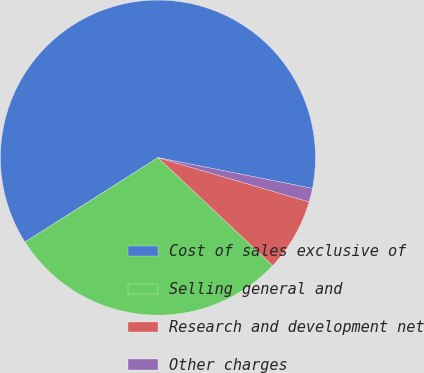Convert chart to OTSL. <chart><loc_0><loc_0><loc_500><loc_500><pie_chart><fcel>Cost of sales exclusive of<fcel>Selling general and<fcel>Research and development net<fcel>Other charges<nl><fcel>62.13%<fcel>28.98%<fcel>7.48%<fcel>1.41%<nl></chart> 